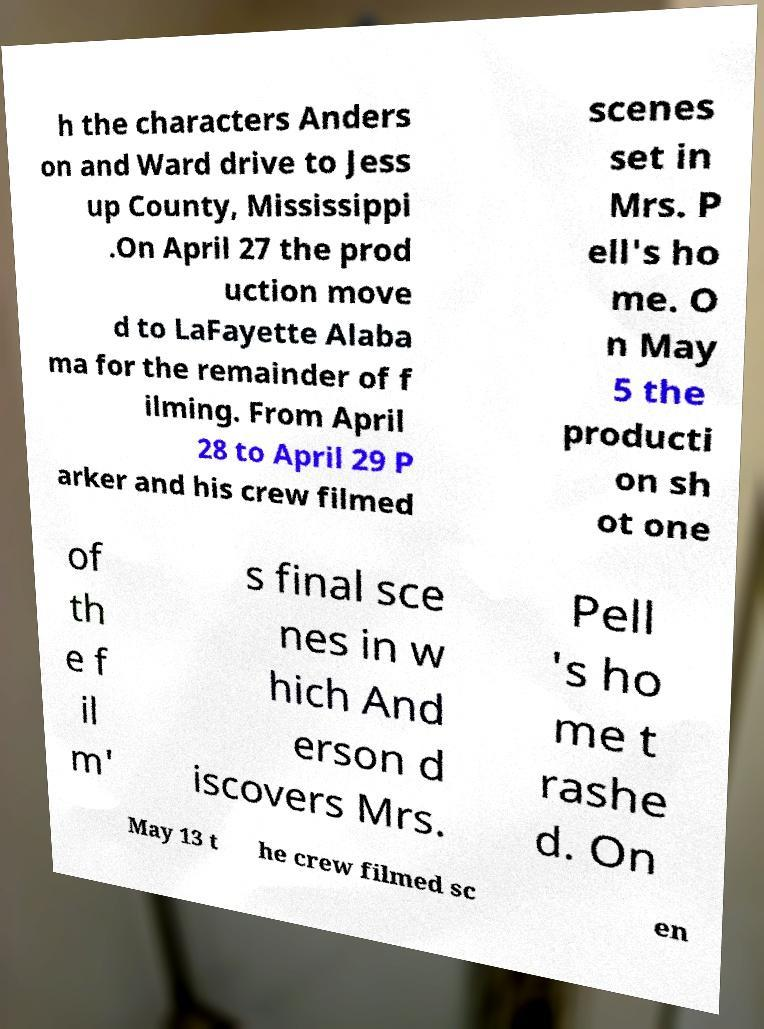Could you assist in decoding the text presented in this image and type it out clearly? h the characters Anders on and Ward drive to Jess up County, Mississippi .On April 27 the prod uction move d to LaFayette Alaba ma for the remainder of f ilming. From April 28 to April 29 P arker and his crew filmed scenes set in Mrs. P ell's ho me. O n May 5 the producti on sh ot one of th e f il m' s final sce nes in w hich And erson d iscovers Mrs. Pell 's ho me t rashe d. On May 13 t he crew filmed sc en 